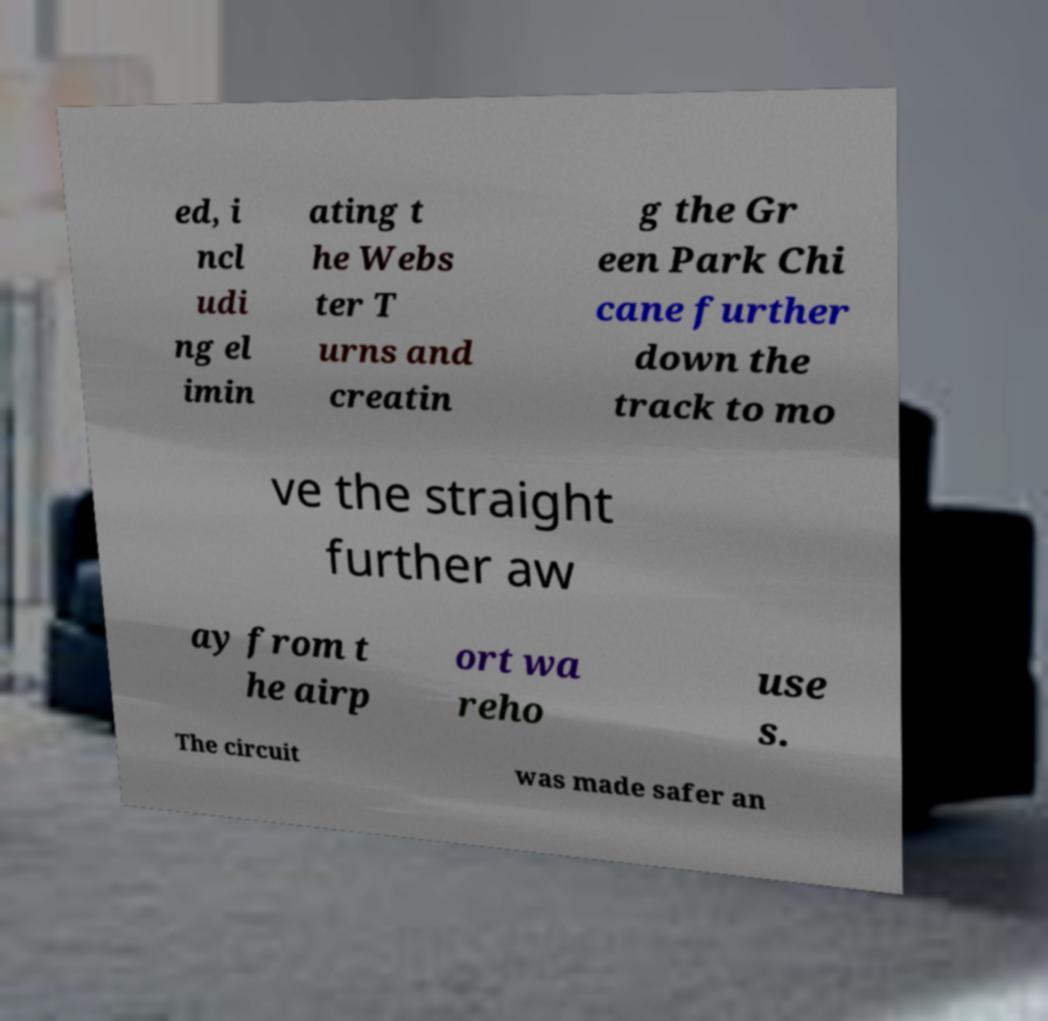There's text embedded in this image that I need extracted. Can you transcribe it verbatim? ed, i ncl udi ng el imin ating t he Webs ter T urns and creatin g the Gr een Park Chi cane further down the track to mo ve the straight further aw ay from t he airp ort wa reho use s. The circuit was made safer an 